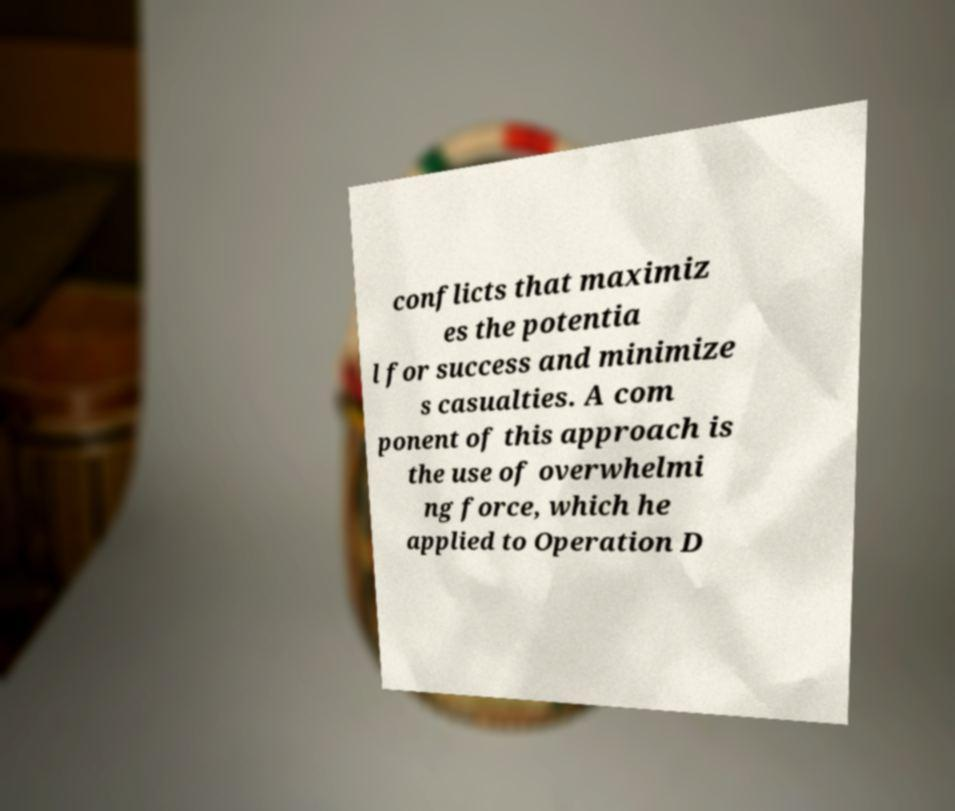Can you read and provide the text displayed in the image?This photo seems to have some interesting text. Can you extract and type it out for me? conflicts that maximiz es the potentia l for success and minimize s casualties. A com ponent of this approach is the use of overwhelmi ng force, which he applied to Operation D 